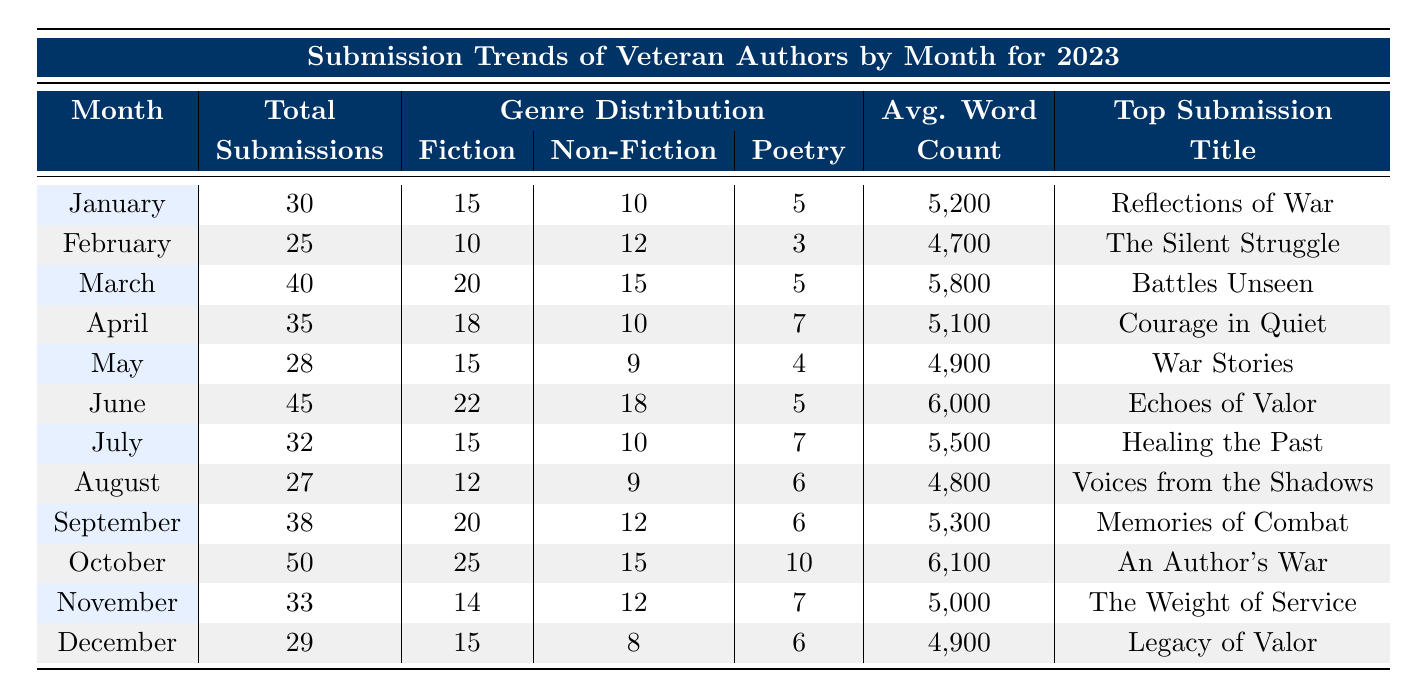What month had the highest number of submissions? The months are listed in order, and October has the highest total submissions at 50.
Answer: October In which month was the average word count the highest? The average word count for each month is listed in the table. June has the highest average word count at 6000.
Answer: June How many total submissions were made from January to March? The total submissions for January, February, and March are 30, 25, and 40 respectively. Adding these gives 30 + 25 + 40 = 95.
Answer: 95 Did the total submissions increase from May to June? May had 28 submissions and June had 45 submissions. Since 45 is greater than 28, total submissions increased from May to June.
Answer: Yes What was the top submission title in September? The table lists "Memories of Combat" as the top submission title for September.
Answer: Memories of Combat Which month had the least amount of submissions and what was the total for that month? By checking the total submissions for each month, February has the least with 25 total submissions.
Answer: February, 25 What is the average number of submissions per month for the year? We take the total submissions (30 + 25 + 40 + 35 + 28 + 45 + 32 + 27 + 38 + 50 + 33 + 29 =  408) and divide by 12 months, which gives 408 / 12 = 34.
Answer: 34 Which genre had the most submissions in June? The genre distribution for June shows 22 submissions for Fiction, the most among the three genres listed.
Answer: Fiction Was the average word count in July higher than in April? July's average word count is 5500, while April's is 5100. Since 5500 is greater than 5100, July’s average word count is higher.
Answer: Yes 